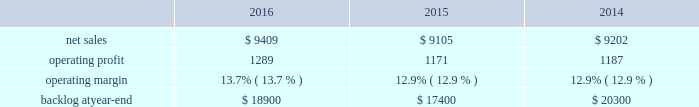Segment includes awe and our share of earnings for our investment in ula , which provides expendable launch services to the u.s .
Government .
Space systems 2019 operating results included the following ( in millions ) : .
2016 compared to 2015 space systems 2019 net sales in 2016 increased $ 304 million , or 3% ( 3 % ) , compared to 2015 .
The increase was attributable to net sales of approximately $ 410 million from awe following the consolidation of this business in the third quarter of 2016 ; and approximately $ 150 million for commercial space transportation programs due to increased launch-related activities ; and approximately $ 70 million of higher net sales for various programs ( primarily fleet ballistic missiles ) due to increased volume .
These increases were partially offset by a decrease in net sales of approximately $ 340 million for government satellite programs due to decreased volume ( primarily sbirs and muos ) and the wind-down or completion of mission solutions programs .
Space systems 2019 operating profit in 2016 increased $ 118 million , or 10% ( 10 % ) , compared to 2015 .
The increase was primarily attributable to a non-cash , pre-tax gain of approximately $ 127 million related to the consolidation of awe ; and approximately $ 80 million of increased equity earnings from joint ventures ( primarily ula ) .
These increases were partially offset by a decrease of approximately $ 105 million for government satellite programs due to lower risk retirements ( primarily sbirs , muos and mission solutions programs ) and decreased volume .
Adjustments not related to volume , including net profit booking rate adjustments , were approximately $ 185 million lower in 2016 compared to 2015 .
2015 compared to 2014 space systems 2019 net sales in 2015 decreased $ 97 million , or 1% ( 1 % ) , compared to 2014 .
The decrease was attributable to approximately $ 335 million lower net sales for government satellite programs due to decreased volume ( primarily aehf ) and the wind-down or completion of mission solutions programs ; and approximately $ 55 million for strategic missile and defense systems due to lower volume .
These decreases were partially offset by higher net sales of approximately $ 235 million for businesses acquired in 2014 ; and approximately $ 75 million for the orion program due to increased volume .
Space systems 2019 operating profit in 2015 decreased $ 16 million , or 1% ( 1 % ) , compared to 2014 .
Operating profit increased approximately $ 85 million for government satellite programs due primarily to increased risk retirements .
This increase was offset by lower operating profit of approximately $ 65 million for commercial satellite programs due to performance matters on certain programs ; and approximately $ 35 million due to decreased equity earnings in joint ventures .
Adjustments not related to volume , including net profit booking rate adjustments and other matters , were approximately $ 105 million higher in 2015 compared to 2014 .
Equity earnings total equity earnings recognized by space systems ( primarily ula ) represented approximately $ 325 million , $ 245 million and $ 280 million , or 25% ( 25 % ) , 21% ( 21 % ) and 24% ( 24 % ) of this business segment 2019s operating profit during 2016 , 2015 and backlog backlog increased in 2016 compared to 2015 primarily due to the addition of awe 2019s backlog .
Backlog decreased in 2015 compared to 2014 primarily due to lower orders for government satellite programs and the orion program and higher sales on the orion program .
Trends we expect space systems 2019 2017 net sales to decrease in the mid-single digit percentage range as compared to 2016 , driven by program lifecycles on government satellite programs , partially offset by the recognition of awe net sales for a full year in 2017 versus a partial year in 2016 following the consolidation of awe in the third quarter of 2016 .
Operating profit .
What were average net sales for space systems in millions between 2014 and 2016? 
Computations: table_average(net sales, none)
Answer: 9238.66667. 